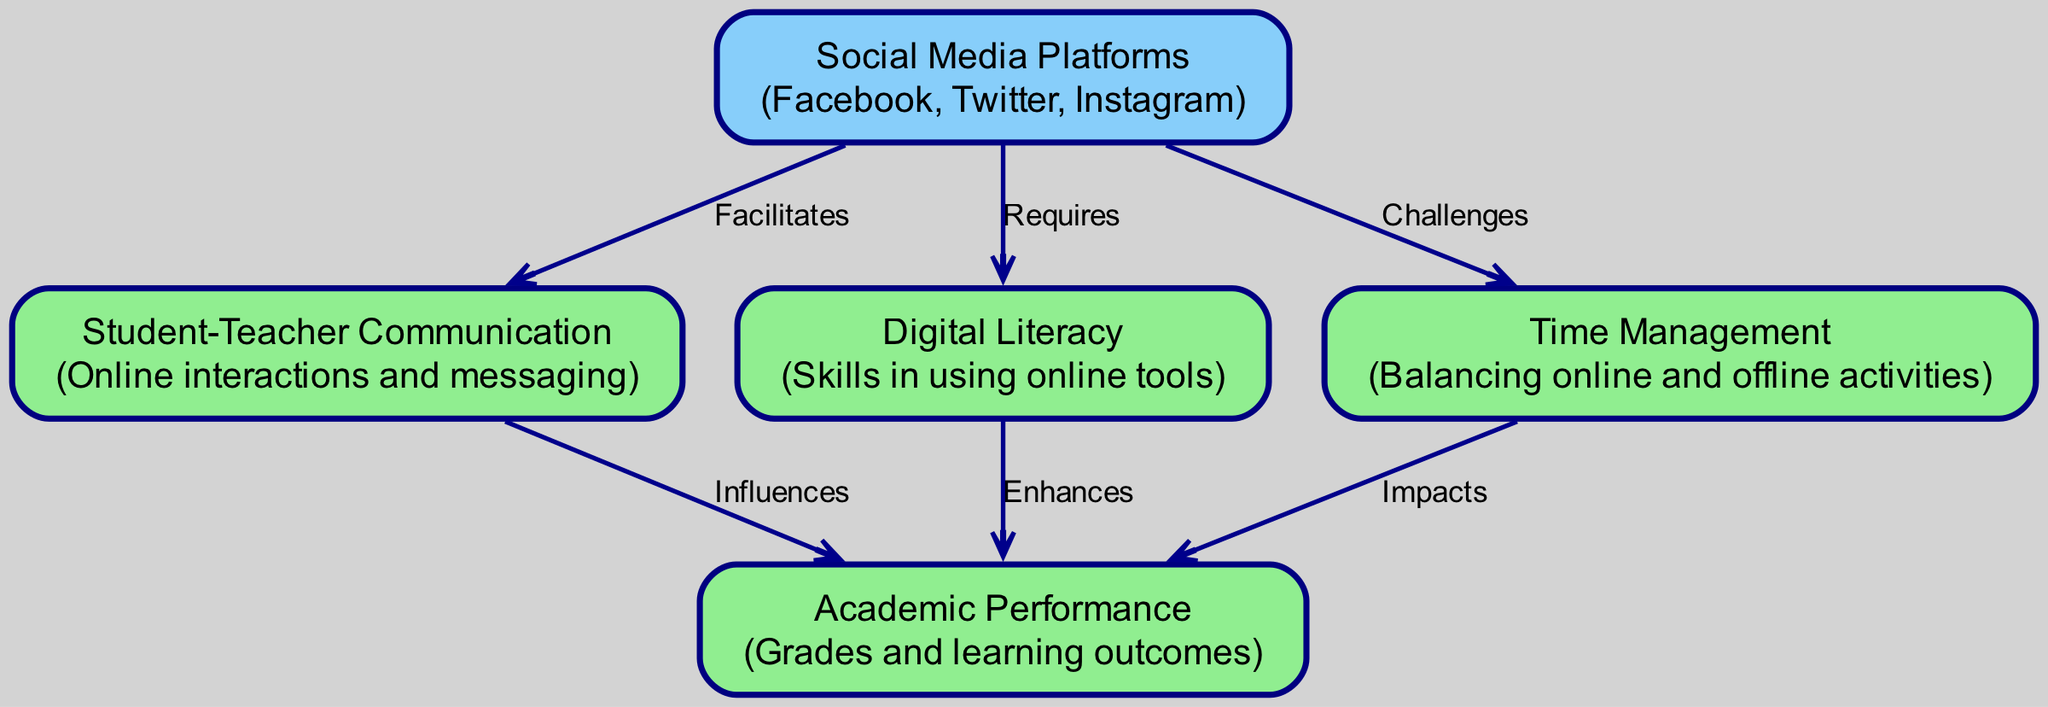What are the three social media platforms mentioned in the diagram? The diagram includes nodes that list the social media platforms as "Facebook," "Twitter," and "Instagram."
Answer: Facebook, Twitter, Instagram How many nodes are present in the diagram? The diagram has a total of five nodes: Social Media Platforms, Student-Teacher Communication, Academic Performance, Digital Literacy, and Time Management.
Answer: 5 What does the edge labeled "Facilitates" connect? The "Facilitates" edge connects "Social Media Platforms" (node 1) to "Student-Teacher Communication" (node 2), indicating a direct relationship.
Answer: Social Media Platforms to Student-Teacher Communication Which node enhances academic performance? The node "Digital Literacy" (node 4) is identified as enhancing academic performance, shown by the directed edge from Digital Literacy to Academic Performance.
Answer: Digital Literacy What is the impact of time management on academic performance according to the diagram? The diagram demonstrates that "Time Management" (node 5) impacts "Academic Performance" (node 3), with a directed edge indicating a negative influence or challenge in balancing activities.
Answer: Impacts What does the arrow from social media platforms to digital literacy signify? The arrow indicates that social media platforms require digital literacy skills to effectively utilize them, as represented by the edge labeled "Requires."
Answer: Requires How many edges are in the diagram? The diagram has six edges that represent different relationships between the five nodes, connecting them in a flowchart structure.
Answer: 6 What does the edge labeled "Challenges" connect? The "Challenges" edge connects "Social Media Platforms" (node 1) to "Time Management" (node 5), indicating a potential issue in balancing online and offline activities.
Answer: Social Media Platforms to Time Management Which relationship indicates a direct influence on academic performance? The directed edge labeled "Influences" connects "Student-Teacher Communication" (node 2) to "Academic Performance" (node 3), showcasing a direct impact.
Answer: Influences 